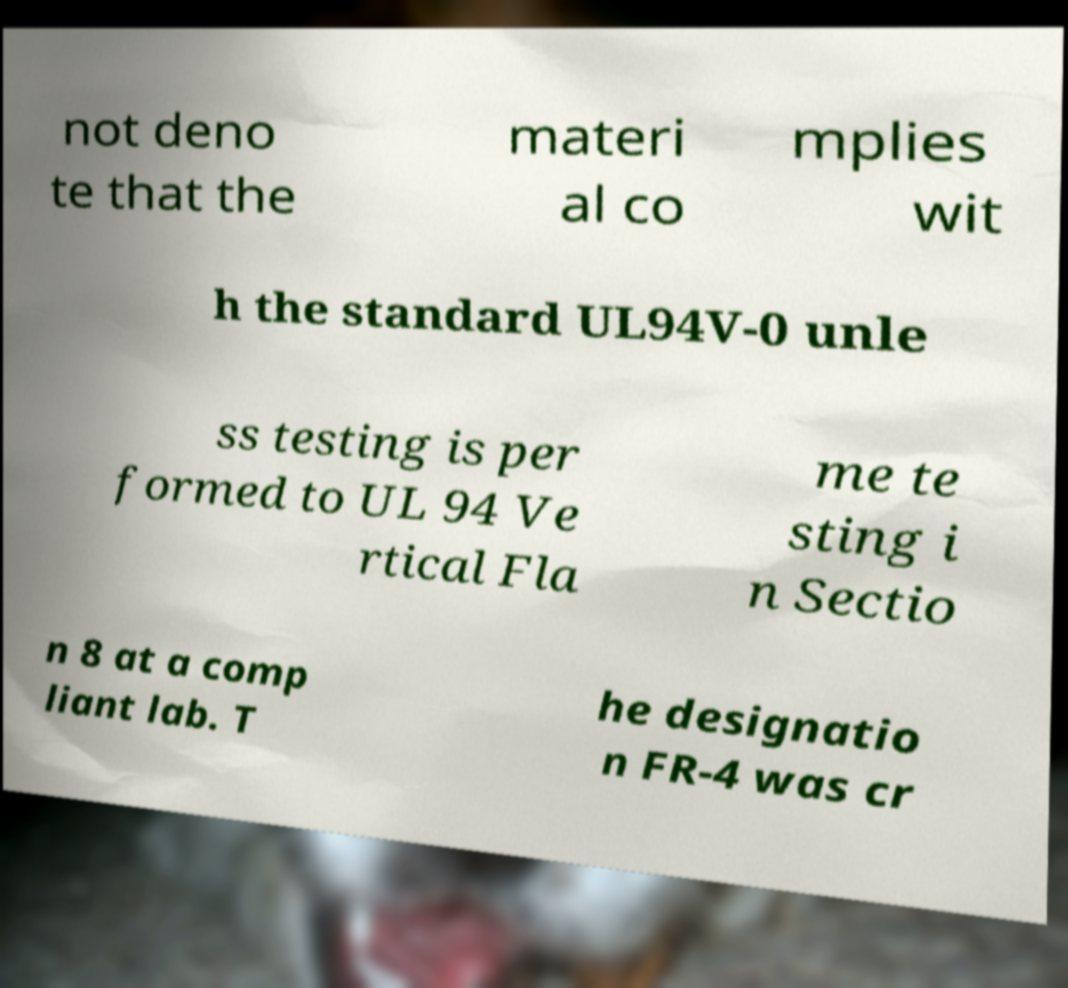Can you read and provide the text displayed in the image?This photo seems to have some interesting text. Can you extract and type it out for me? not deno te that the materi al co mplies wit h the standard UL94V-0 unle ss testing is per formed to UL 94 Ve rtical Fla me te sting i n Sectio n 8 at a comp liant lab. T he designatio n FR-4 was cr 